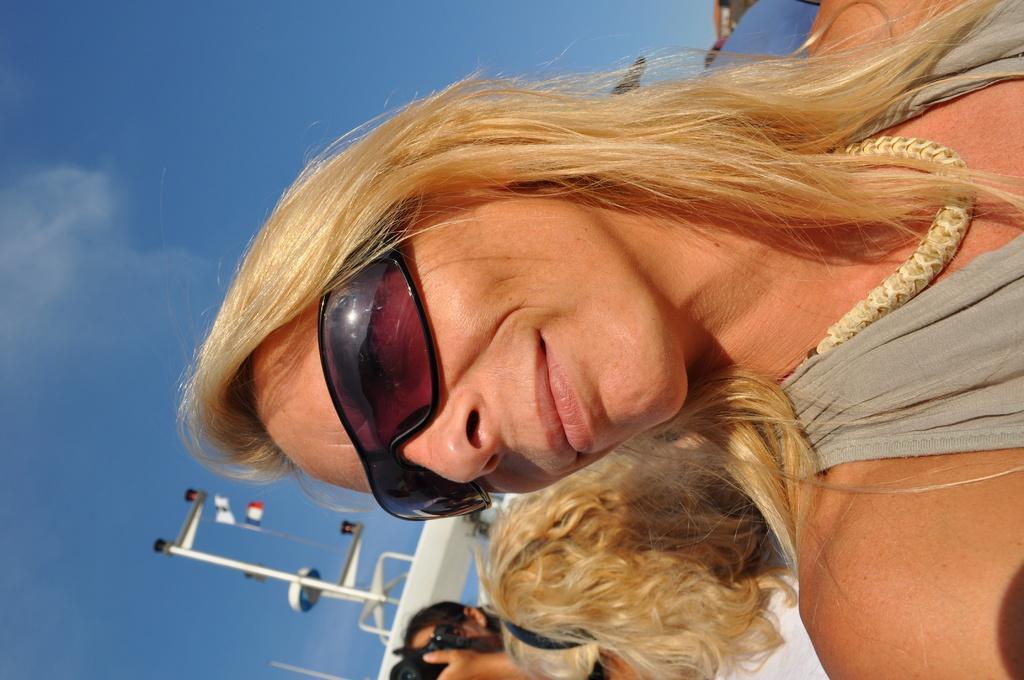In one or two sentences, can you explain what this image depicts? In this picture I can see a woman in the middle, she is wearing goggles. At the bottom I can see the two persons, on the left side there are flags and metal rods and also I can see the sky in the background. 